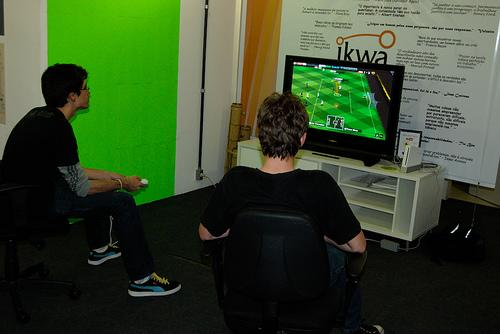Describe the floor covering and the wall decoration in the room. The floor is carpeted, and there is green paper on the white wall. Assess the mood and atmosphere in the room based on the image information. The mood and atmosphere in the room seem to be lively and entertaining, as the teenage boys are enjoying a fun video game break. State the location and style of the chairs the boys are using during their gaming session. The boys are sitting on black swivel chairs in front of the TV. Identify the main gaming accessory the boys are using to play their video game. The main gaming accessory the boys are using is the Nintendo Wiimote. What kind of video game are the boys playing, and on which gaming system? The boys are playing a soccer video game on a Nintendo Wii gaming system. How many individuals are in the room, and are there any women present? There are two individuals in the room, and no women are present. Provide a brief description of the scene in the image. Two teenage boys are playing a soccer video game on a Nintendo Wii while sitting on black swivel chairs in a room with carpeted floor and a green paper on the wall. What type of screen is used to display their video game, and what is positioned next to it? A flat screen TV on a stand is used for displaying the game, and a white Wii is positioned next to it. Enumerate the colors featured on the sneakers one of the boys is wearing. The sneakers are black with white, blue, and yellow accents. Calculate the total number of chairs present within the room. There are two black chairs in the room. Spot the dog laying underneath the chair. No, it's not mentioned in the image. 